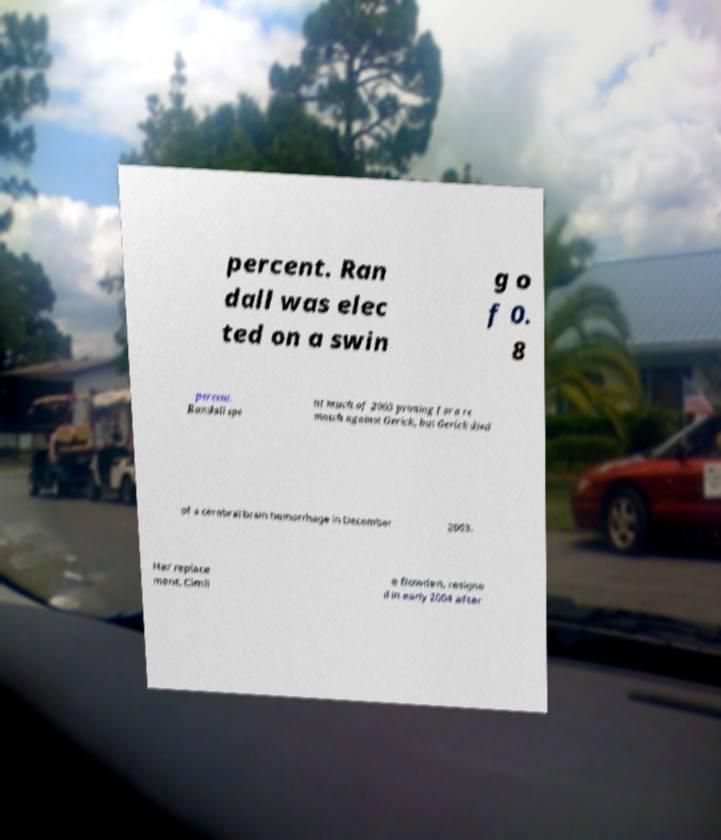There's text embedded in this image that I need extracted. Can you transcribe it verbatim? percent. Ran dall was elec ted on a swin g o f 0. 8 percent. Randall spe nt much of 2003 priming for a re match against Gerick, but Gerick died of a cerebral brain hemorrhage in December 2003. Her replace ment, Cimli e Bowden, resigne d in early 2004 after 